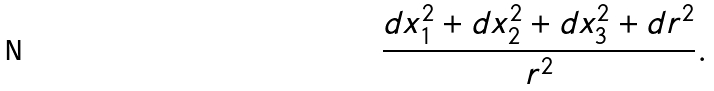Convert formula to latex. <formula><loc_0><loc_0><loc_500><loc_500>\frac { d x _ { 1 } ^ { 2 } + d x _ { 2 } ^ { 2 } + d x _ { 3 } ^ { 2 } + d r ^ { 2 } } { r ^ { 2 } } .</formula> 